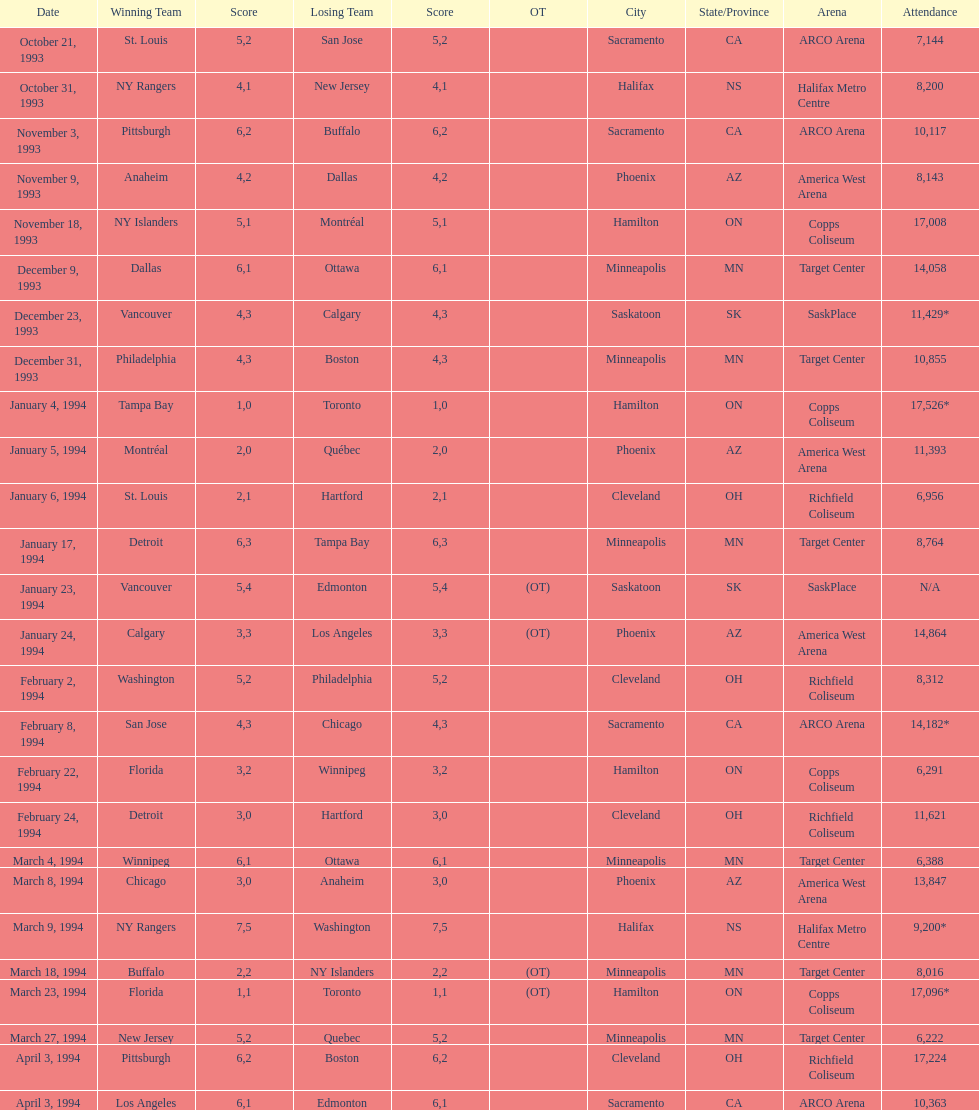When was the first neutral site game to be won by tampa bay? January 4, 1994. 